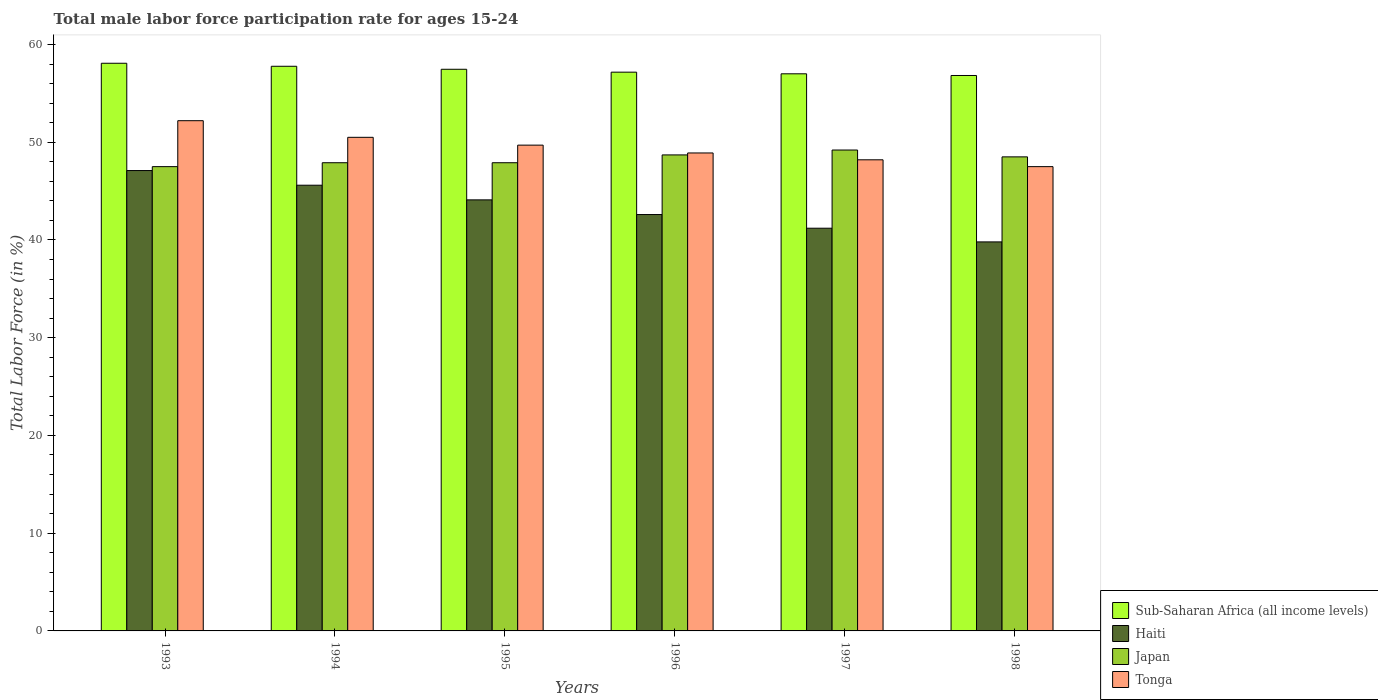How many groups of bars are there?
Provide a short and direct response. 6. Are the number of bars on each tick of the X-axis equal?
Ensure brevity in your answer.  Yes. How many bars are there on the 5th tick from the left?
Offer a terse response. 4. How many bars are there on the 1st tick from the right?
Give a very brief answer. 4. What is the male labor force participation rate in Haiti in 1995?
Your answer should be very brief. 44.1. Across all years, what is the maximum male labor force participation rate in Sub-Saharan Africa (all income levels)?
Offer a terse response. 58.08. Across all years, what is the minimum male labor force participation rate in Japan?
Ensure brevity in your answer.  47.5. In which year was the male labor force participation rate in Tonga minimum?
Ensure brevity in your answer.  1998. What is the total male labor force participation rate in Haiti in the graph?
Offer a terse response. 260.4. What is the difference between the male labor force participation rate in Sub-Saharan Africa (all income levels) in 1997 and that in 1998?
Your response must be concise. 0.17. What is the difference between the male labor force participation rate in Japan in 1993 and the male labor force participation rate in Sub-Saharan Africa (all income levels) in 1995?
Your response must be concise. -9.96. What is the average male labor force participation rate in Tonga per year?
Your response must be concise. 49.5. In the year 1995, what is the difference between the male labor force participation rate in Tonga and male labor force participation rate in Sub-Saharan Africa (all income levels)?
Your answer should be compact. -7.76. In how many years, is the male labor force participation rate in Sub-Saharan Africa (all income levels) greater than 52 %?
Make the answer very short. 6. What is the ratio of the male labor force participation rate in Haiti in 1994 to that in 1998?
Ensure brevity in your answer.  1.15. Is the male labor force participation rate in Tonga in 1995 less than that in 1998?
Keep it short and to the point. No. Is the difference between the male labor force participation rate in Tonga in 1995 and 1996 greater than the difference between the male labor force participation rate in Sub-Saharan Africa (all income levels) in 1995 and 1996?
Provide a short and direct response. Yes. What is the difference between the highest and the second highest male labor force participation rate in Haiti?
Ensure brevity in your answer.  1.5. What is the difference between the highest and the lowest male labor force participation rate in Japan?
Keep it short and to the point. 1.7. What does the 2nd bar from the left in 1997 represents?
Ensure brevity in your answer.  Haiti. What does the 2nd bar from the right in 1996 represents?
Your response must be concise. Japan. Is it the case that in every year, the sum of the male labor force participation rate in Haiti and male labor force participation rate in Tonga is greater than the male labor force participation rate in Japan?
Your answer should be compact. Yes. How many bars are there?
Keep it short and to the point. 24. Are all the bars in the graph horizontal?
Your answer should be compact. No. What is the difference between two consecutive major ticks on the Y-axis?
Make the answer very short. 10. Where does the legend appear in the graph?
Keep it short and to the point. Bottom right. How are the legend labels stacked?
Give a very brief answer. Vertical. What is the title of the graph?
Ensure brevity in your answer.  Total male labor force participation rate for ages 15-24. Does "Mauritania" appear as one of the legend labels in the graph?
Provide a short and direct response. No. What is the Total Labor Force (in %) of Sub-Saharan Africa (all income levels) in 1993?
Offer a very short reply. 58.08. What is the Total Labor Force (in %) in Haiti in 1993?
Your response must be concise. 47.1. What is the Total Labor Force (in %) of Japan in 1993?
Keep it short and to the point. 47.5. What is the Total Labor Force (in %) of Tonga in 1993?
Ensure brevity in your answer.  52.2. What is the Total Labor Force (in %) in Sub-Saharan Africa (all income levels) in 1994?
Your answer should be compact. 57.77. What is the Total Labor Force (in %) in Haiti in 1994?
Make the answer very short. 45.6. What is the Total Labor Force (in %) in Japan in 1994?
Your response must be concise. 47.9. What is the Total Labor Force (in %) in Tonga in 1994?
Provide a short and direct response. 50.5. What is the Total Labor Force (in %) in Sub-Saharan Africa (all income levels) in 1995?
Make the answer very short. 57.46. What is the Total Labor Force (in %) in Haiti in 1995?
Your answer should be compact. 44.1. What is the Total Labor Force (in %) in Japan in 1995?
Your response must be concise. 47.9. What is the Total Labor Force (in %) in Tonga in 1995?
Your answer should be compact. 49.7. What is the Total Labor Force (in %) of Sub-Saharan Africa (all income levels) in 1996?
Provide a succinct answer. 57.17. What is the Total Labor Force (in %) of Haiti in 1996?
Keep it short and to the point. 42.6. What is the Total Labor Force (in %) in Japan in 1996?
Offer a terse response. 48.7. What is the Total Labor Force (in %) of Tonga in 1996?
Your answer should be compact. 48.9. What is the Total Labor Force (in %) in Sub-Saharan Africa (all income levels) in 1997?
Your response must be concise. 57. What is the Total Labor Force (in %) in Haiti in 1997?
Your answer should be very brief. 41.2. What is the Total Labor Force (in %) of Japan in 1997?
Keep it short and to the point. 49.2. What is the Total Labor Force (in %) in Tonga in 1997?
Provide a short and direct response. 48.2. What is the Total Labor Force (in %) of Sub-Saharan Africa (all income levels) in 1998?
Make the answer very short. 56.83. What is the Total Labor Force (in %) of Haiti in 1998?
Give a very brief answer. 39.8. What is the Total Labor Force (in %) in Japan in 1998?
Your answer should be very brief. 48.5. What is the Total Labor Force (in %) in Tonga in 1998?
Offer a very short reply. 47.5. Across all years, what is the maximum Total Labor Force (in %) of Sub-Saharan Africa (all income levels)?
Offer a terse response. 58.08. Across all years, what is the maximum Total Labor Force (in %) of Haiti?
Give a very brief answer. 47.1. Across all years, what is the maximum Total Labor Force (in %) of Japan?
Make the answer very short. 49.2. Across all years, what is the maximum Total Labor Force (in %) of Tonga?
Your response must be concise. 52.2. Across all years, what is the minimum Total Labor Force (in %) of Sub-Saharan Africa (all income levels)?
Offer a terse response. 56.83. Across all years, what is the minimum Total Labor Force (in %) in Haiti?
Provide a succinct answer. 39.8. Across all years, what is the minimum Total Labor Force (in %) in Japan?
Offer a very short reply. 47.5. Across all years, what is the minimum Total Labor Force (in %) of Tonga?
Keep it short and to the point. 47.5. What is the total Total Labor Force (in %) in Sub-Saharan Africa (all income levels) in the graph?
Provide a short and direct response. 344.3. What is the total Total Labor Force (in %) in Haiti in the graph?
Make the answer very short. 260.4. What is the total Total Labor Force (in %) in Japan in the graph?
Your answer should be compact. 289.7. What is the total Total Labor Force (in %) in Tonga in the graph?
Your answer should be very brief. 297. What is the difference between the Total Labor Force (in %) in Sub-Saharan Africa (all income levels) in 1993 and that in 1994?
Offer a terse response. 0.31. What is the difference between the Total Labor Force (in %) of Japan in 1993 and that in 1994?
Keep it short and to the point. -0.4. What is the difference between the Total Labor Force (in %) in Sub-Saharan Africa (all income levels) in 1993 and that in 1995?
Offer a terse response. 0.62. What is the difference between the Total Labor Force (in %) in Haiti in 1993 and that in 1995?
Provide a short and direct response. 3. What is the difference between the Total Labor Force (in %) of Tonga in 1993 and that in 1995?
Offer a terse response. 2.5. What is the difference between the Total Labor Force (in %) of Sub-Saharan Africa (all income levels) in 1993 and that in 1996?
Ensure brevity in your answer.  0.91. What is the difference between the Total Labor Force (in %) in Japan in 1993 and that in 1996?
Keep it short and to the point. -1.2. What is the difference between the Total Labor Force (in %) of Tonga in 1993 and that in 1996?
Ensure brevity in your answer.  3.3. What is the difference between the Total Labor Force (in %) in Sub-Saharan Africa (all income levels) in 1993 and that in 1997?
Keep it short and to the point. 1.08. What is the difference between the Total Labor Force (in %) in Haiti in 1993 and that in 1997?
Offer a terse response. 5.9. What is the difference between the Total Labor Force (in %) of Sub-Saharan Africa (all income levels) in 1993 and that in 1998?
Offer a terse response. 1.25. What is the difference between the Total Labor Force (in %) in Japan in 1993 and that in 1998?
Your response must be concise. -1. What is the difference between the Total Labor Force (in %) of Tonga in 1993 and that in 1998?
Ensure brevity in your answer.  4.7. What is the difference between the Total Labor Force (in %) in Sub-Saharan Africa (all income levels) in 1994 and that in 1995?
Ensure brevity in your answer.  0.31. What is the difference between the Total Labor Force (in %) in Japan in 1994 and that in 1995?
Offer a terse response. 0. What is the difference between the Total Labor Force (in %) of Sub-Saharan Africa (all income levels) in 1994 and that in 1996?
Make the answer very short. 0.6. What is the difference between the Total Labor Force (in %) of Tonga in 1994 and that in 1996?
Give a very brief answer. 1.6. What is the difference between the Total Labor Force (in %) in Sub-Saharan Africa (all income levels) in 1994 and that in 1997?
Keep it short and to the point. 0.77. What is the difference between the Total Labor Force (in %) in Haiti in 1994 and that in 1997?
Make the answer very short. 4.4. What is the difference between the Total Labor Force (in %) in Japan in 1994 and that in 1997?
Your answer should be compact. -1.3. What is the difference between the Total Labor Force (in %) in Sub-Saharan Africa (all income levels) in 1994 and that in 1998?
Provide a short and direct response. 0.94. What is the difference between the Total Labor Force (in %) in Sub-Saharan Africa (all income levels) in 1995 and that in 1996?
Ensure brevity in your answer.  0.29. What is the difference between the Total Labor Force (in %) in Haiti in 1995 and that in 1996?
Provide a short and direct response. 1.5. What is the difference between the Total Labor Force (in %) of Japan in 1995 and that in 1996?
Your answer should be very brief. -0.8. What is the difference between the Total Labor Force (in %) of Sub-Saharan Africa (all income levels) in 1995 and that in 1997?
Your answer should be compact. 0.46. What is the difference between the Total Labor Force (in %) of Haiti in 1995 and that in 1997?
Provide a succinct answer. 2.9. What is the difference between the Total Labor Force (in %) in Tonga in 1995 and that in 1997?
Ensure brevity in your answer.  1.5. What is the difference between the Total Labor Force (in %) of Sub-Saharan Africa (all income levels) in 1995 and that in 1998?
Provide a short and direct response. 0.64. What is the difference between the Total Labor Force (in %) in Haiti in 1995 and that in 1998?
Your answer should be very brief. 4.3. What is the difference between the Total Labor Force (in %) in Japan in 1995 and that in 1998?
Ensure brevity in your answer.  -0.6. What is the difference between the Total Labor Force (in %) in Tonga in 1995 and that in 1998?
Your answer should be very brief. 2.2. What is the difference between the Total Labor Force (in %) of Sub-Saharan Africa (all income levels) in 1996 and that in 1997?
Ensure brevity in your answer.  0.17. What is the difference between the Total Labor Force (in %) of Japan in 1996 and that in 1997?
Offer a very short reply. -0.5. What is the difference between the Total Labor Force (in %) of Tonga in 1996 and that in 1997?
Offer a very short reply. 0.7. What is the difference between the Total Labor Force (in %) in Sub-Saharan Africa (all income levels) in 1996 and that in 1998?
Provide a short and direct response. 0.34. What is the difference between the Total Labor Force (in %) in Japan in 1996 and that in 1998?
Give a very brief answer. 0.2. What is the difference between the Total Labor Force (in %) in Sub-Saharan Africa (all income levels) in 1997 and that in 1998?
Offer a very short reply. 0.17. What is the difference between the Total Labor Force (in %) in Sub-Saharan Africa (all income levels) in 1993 and the Total Labor Force (in %) in Haiti in 1994?
Your response must be concise. 12.48. What is the difference between the Total Labor Force (in %) in Sub-Saharan Africa (all income levels) in 1993 and the Total Labor Force (in %) in Japan in 1994?
Give a very brief answer. 10.18. What is the difference between the Total Labor Force (in %) of Sub-Saharan Africa (all income levels) in 1993 and the Total Labor Force (in %) of Tonga in 1994?
Give a very brief answer. 7.58. What is the difference between the Total Labor Force (in %) of Haiti in 1993 and the Total Labor Force (in %) of Japan in 1994?
Your answer should be compact. -0.8. What is the difference between the Total Labor Force (in %) in Haiti in 1993 and the Total Labor Force (in %) in Tonga in 1994?
Make the answer very short. -3.4. What is the difference between the Total Labor Force (in %) of Japan in 1993 and the Total Labor Force (in %) of Tonga in 1994?
Ensure brevity in your answer.  -3. What is the difference between the Total Labor Force (in %) in Sub-Saharan Africa (all income levels) in 1993 and the Total Labor Force (in %) in Haiti in 1995?
Give a very brief answer. 13.98. What is the difference between the Total Labor Force (in %) in Sub-Saharan Africa (all income levels) in 1993 and the Total Labor Force (in %) in Japan in 1995?
Give a very brief answer. 10.18. What is the difference between the Total Labor Force (in %) in Sub-Saharan Africa (all income levels) in 1993 and the Total Labor Force (in %) in Tonga in 1995?
Offer a terse response. 8.38. What is the difference between the Total Labor Force (in %) of Sub-Saharan Africa (all income levels) in 1993 and the Total Labor Force (in %) of Haiti in 1996?
Your answer should be very brief. 15.48. What is the difference between the Total Labor Force (in %) of Sub-Saharan Africa (all income levels) in 1993 and the Total Labor Force (in %) of Japan in 1996?
Offer a terse response. 9.38. What is the difference between the Total Labor Force (in %) in Sub-Saharan Africa (all income levels) in 1993 and the Total Labor Force (in %) in Tonga in 1996?
Offer a terse response. 9.18. What is the difference between the Total Labor Force (in %) in Haiti in 1993 and the Total Labor Force (in %) in Japan in 1996?
Make the answer very short. -1.6. What is the difference between the Total Labor Force (in %) in Sub-Saharan Africa (all income levels) in 1993 and the Total Labor Force (in %) in Haiti in 1997?
Offer a terse response. 16.88. What is the difference between the Total Labor Force (in %) of Sub-Saharan Africa (all income levels) in 1993 and the Total Labor Force (in %) of Japan in 1997?
Give a very brief answer. 8.88. What is the difference between the Total Labor Force (in %) of Sub-Saharan Africa (all income levels) in 1993 and the Total Labor Force (in %) of Tonga in 1997?
Offer a very short reply. 9.88. What is the difference between the Total Labor Force (in %) in Haiti in 1993 and the Total Labor Force (in %) in Japan in 1997?
Offer a terse response. -2.1. What is the difference between the Total Labor Force (in %) of Haiti in 1993 and the Total Labor Force (in %) of Tonga in 1997?
Make the answer very short. -1.1. What is the difference between the Total Labor Force (in %) in Sub-Saharan Africa (all income levels) in 1993 and the Total Labor Force (in %) in Haiti in 1998?
Provide a short and direct response. 18.28. What is the difference between the Total Labor Force (in %) of Sub-Saharan Africa (all income levels) in 1993 and the Total Labor Force (in %) of Japan in 1998?
Your answer should be very brief. 9.58. What is the difference between the Total Labor Force (in %) of Sub-Saharan Africa (all income levels) in 1993 and the Total Labor Force (in %) of Tonga in 1998?
Your answer should be compact. 10.58. What is the difference between the Total Labor Force (in %) of Haiti in 1993 and the Total Labor Force (in %) of Japan in 1998?
Provide a succinct answer. -1.4. What is the difference between the Total Labor Force (in %) of Haiti in 1993 and the Total Labor Force (in %) of Tonga in 1998?
Offer a terse response. -0.4. What is the difference between the Total Labor Force (in %) of Sub-Saharan Africa (all income levels) in 1994 and the Total Labor Force (in %) of Haiti in 1995?
Provide a short and direct response. 13.67. What is the difference between the Total Labor Force (in %) in Sub-Saharan Africa (all income levels) in 1994 and the Total Labor Force (in %) in Japan in 1995?
Your response must be concise. 9.87. What is the difference between the Total Labor Force (in %) in Sub-Saharan Africa (all income levels) in 1994 and the Total Labor Force (in %) in Tonga in 1995?
Offer a terse response. 8.07. What is the difference between the Total Labor Force (in %) in Haiti in 1994 and the Total Labor Force (in %) in Japan in 1995?
Give a very brief answer. -2.3. What is the difference between the Total Labor Force (in %) of Haiti in 1994 and the Total Labor Force (in %) of Tonga in 1995?
Your answer should be compact. -4.1. What is the difference between the Total Labor Force (in %) of Japan in 1994 and the Total Labor Force (in %) of Tonga in 1995?
Give a very brief answer. -1.8. What is the difference between the Total Labor Force (in %) in Sub-Saharan Africa (all income levels) in 1994 and the Total Labor Force (in %) in Haiti in 1996?
Provide a succinct answer. 15.17. What is the difference between the Total Labor Force (in %) in Sub-Saharan Africa (all income levels) in 1994 and the Total Labor Force (in %) in Japan in 1996?
Your answer should be very brief. 9.07. What is the difference between the Total Labor Force (in %) in Sub-Saharan Africa (all income levels) in 1994 and the Total Labor Force (in %) in Tonga in 1996?
Your answer should be compact. 8.87. What is the difference between the Total Labor Force (in %) in Haiti in 1994 and the Total Labor Force (in %) in Tonga in 1996?
Your answer should be very brief. -3.3. What is the difference between the Total Labor Force (in %) in Japan in 1994 and the Total Labor Force (in %) in Tonga in 1996?
Ensure brevity in your answer.  -1. What is the difference between the Total Labor Force (in %) of Sub-Saharan Africa (all income levels) in 1994 and the Total Labor Force (in %) of Haiti in 1997?
Offer a terse response. 16.57. What is the difference between the Total Labor Force (in %) of Sub-Saharan Africa (all income levels) in 1994 and the Total Labor Force (in %) of Japan in 1997?
Your response must be concise. 8.57. What is the difference between the Total Labor Force (in %) in Sub-Saharan Africa (all income levels) in 1994 and the Total Labor Force (in %) in Tonga in 1997?
Your answer should be very brief. 9.57. What is the difference between the Total Labor Force (in %) in Haiti in 1994 and the Total Labor Force (in %) in Japan in 1997?
Provide a short and direct response. -3.6. What is the difference between the Total Labor Force (in %) in Haiti in 1994 and the Total Labor Force (in %) in Tonga in 1997?
Offer a very short reply. -2.6. What is the difference between the Total Labor Force (in %) of Japan in 1994 and the Total Labor Force (in %) of Tonga in 1997?
Your response must be concise. -0.3. What is the difference between the Total Labor Force (in %) of Sub-Saharan Africa (all income levels) in 1994 and the Total Labor Force (in %) of Haiti in 1998?
Offer a very short reply. 17.97. What is the difference between the Total Labor Force (in %) of Sub-Saharan Africa (all income levels) in 1994 and the Total Labor Force (in %) of Japan in 1998?
Provide a short and direct response. 9.27. What is the difference between the Total Labor Force (in %) of Sub-Saharan Africa (all income levels) in 1994 and the Total Labor Force (in %) of Tonga in 1998?
Give a very brief answer. 10.27. What is the difference between the Total Labor Force (in %) of Japan in 1994 and the Total Labor Force (in %) of Tonga in 1998?
Provide a succinct answer. 0.4. What is the difference between the Total Labor Force (in %) in Sub-Saharan Africa (all income levels) in 1995 and the Total Labor Force (in %) in Haiti in 1996?
Offer a very short reply. 14.86. What is the difference between the Total Labor Force (in %) of Sub-Saharan Africa (all income levels) in 1995 and the Total Labor Force (in %) of Japan in 1996?
Offer a very short reply. 8.76. What is the difference between the Total Labor Force (in %) in Sub-Saharan Africa (all income levels) in 1995 and the Total Labor Force (in %) in Tonga in 1996?
Keep it short and to the point. 8.56. What is the difference between the Total Labor Force (in %) of Haiti in 1995 and the Total Labor Force (in %) of Japan in 1996?
Offer a terse response. -4.6. What is the difference between the Total Labor Force (in %) in Japan in 1995 and the Total Labor Force (in %) in Tonga in 1996?
Provide a succinct answer. -1. What is the difference between the Total Labor Force (in %) in Sub-Saharan Africa (all income levels) in 1995 and the Total Labor Force (in %) in Haiti in 1997?
Give a very brief answer. 16.26. What is the difference between the Total Labor Force (in %) of Sub-Saharan Africa (all income levels) in 1995 and the Total Labor Force (in %) of Japan in 1997?
Provide a succinct answer. 8.26. What is the difference between the Total Labor Force (in %) in Sub-Saharan Africa (all income levels) in 1995 and the Total Labor Force (in %) in Tonga in 1997?
Your answer should be compact. 9.26. What is the difference between the Total Labor Force (in %) in Haiti in 1995 and the Total Labor Force (in %) in Japan in 1997?
Offer a terse response. -5.1. What is the difference between the Total Labor Force (in %) in Haiti in 1995 and the Total Labor Force (in %) in Tonga in 1997?
Give a very brief answer. -4.1. What is the difference between the Total Labor Force (in %) of Sub-Saharan Africa (all income levels) in 1995 and the Total Labor Force (in %) of Haiti in 1998?
Make the answer very short. 17.66. What is the difference between the Total Labor Force (in %) of Sub-Saharan Africa (all income levels) in 1995 and the Total Labor Force (in %) of Japan in 1998?
Ensure brevity in your answer.  8.96. What is the difference between the Total Labor Force (in %) of Sub-Saharan Africa (all income levels) in 1995 and the Total Labor Force (in %) of Tonga in 1998?
Provide a succinct answer. 9.96. What is the difference between the Total Labor Force (in %) in Haiti in 1995 and the Total Labor Force (in %) in Japan in 1998?
Offer a terse response. -4.4. What is the difference between the Total Labor Force (in %) of Haiti in 1995 and the Total Labor Force (in %) of Tonga in 1998?
Keep it short and to the point. -3.4. What is the difference between the Total Labor Force (in %) of Japan in 1995 and the Total Labor Force (in %) of Tonga in 1998?
Your response must be concise. 0.4. What is the difference between the Total Labor Force (in %) of Sub-Saharan Africa (all income levels) in 1996 and the Total Labor Force (in %) of Haiti in 1997?
Ensure brevity in your answer.  15.97. What is the difference between the Total Labor Force (in %) in Sub-Saharan Africa (all income levels) in 1996 and the Total Labor Force (in %) in Japan in 1997?
Provide a short and direct response. 7.97. What is the difference between the Total Labor Force (in %) of Sub-Saharan Africa (all income levels) in 1996 and the Total Labor Force (in %) of Tonga in 1997?
Offer a very short reply. 8.97. What is the difference between the Total Labor Force (in %) in Japan in 1996 and the Total Labor Force (in %) in Tonga in 1997?
Make the answer very short. 0.5. What is the difference between the Total Labor Force (in %) in Sub-Saharan Africa (all income levels) in 1996 and the Total Labor Force (in %) in Haiti in 1998?
Make the answer very short. 17.37. What is the difference between the Total Labor Force (in %) in Sub-Saharan Africa (all income levels) in 1996 and the Total Labor Force (in %) in Japan in 1998?
Ensure brevity in your answer.  8.67. What is the difference between the Total Labor Force (in %) of Sub-Saharan Africa (all income levels) in 1996 and the Total Labor Force (in %) of Tonga in 1998?
Provide a short and direct response. 9.67. What is the difference between the Total Labor Force (in %) in Japan in 1996 and the Total Labor Force (in %) in Tonga in 1998?
Make the answer very short. 1.2. What is the difference between the Total Labor Force (in %) in Sub-Saharan Africa (all income levels) in 1997 and the Total Labor Force (in %) in Haiti in 1998?
Ensure brevity in your answer.  17.2. What is the difference between the Total Labor Force (in %) of Sub-Saharan Africa (all income levels) in 1997 and the Total Labor Force (in %) of Japan in 1998?
Your response must be concise. 8.5. What is the difference between the Total Labor Force (in %) of Sub-Saharan Africa (all income levels) in 1997 and the Total Labor Force (in %) of Tonga in 1998?
Give a very brief answer. 9.5. What is the difference between the Total Labor Force (in %) of Japan in 1997 and the Total Labor Force (in %) of Tonga in 1998?
Your answer should be compact. 1.7. What is the average Total Labor Force (in %) in Sub-Saharan Africa (all income levels) per year?
Keep it short and to the point. 57.38. What is the average Total Labor Force (in %) of Haiti per year?
Your response must be concise. 43.4. What is the average Total Labor Force (in %) in Japan per year?
Provide a succinct answer. 48.28. What is the average Total Labor Force (in %) in Tonga per year?
Make the answer very short. 49.5. In the year 1993, what is the difference between the Total Labor Force (in %) of Sub-Saharan Africa (all income levels) and Total Labor Force (in %) of Haiti?
Your answer should be very brief. 10.98. In the year 1993, what is the difference between the Total Labor Force (in %) in Sub-Saharan Africa (all income levels) and Total Labor Force (in %) in Japan?
Offer a terse response. 10.58. In the year 1993, what is the difference between the Total Labor Force (in %) of Sub-Saharan Africa (all income levels) and Total Labor Force (in %) of Tonga?
Ensure brevity in your answer.  5.88. In the year 1993, what is the difference between the Total Labor Force (in %) of Japan and Total Labor Force (in %) of Tonga?
Your response must be concise. -4.7. In the year 1994, what is the difference between the Total Labor Force (in %) in Sub-Saharan Africa (all income levels) and Total Labor Force (in %) in Haiti?
Make the answer very short. 12.17. In the year 1994, what is the difference between the Total Labor Force (in %) in Sub-Saharan Africa (all income levels) and Total Labor Force (in %) in Japan?
Your answer should be compact. 9.87. In the year 1994, what is the difference between the Total Labor Force (in %) of Sub-Saharan Africa (all income levels) and Total Labor Force (in %) of Tonga?
Offer a terse response. 7.27. In the year 1994, what is the difference between the Total Labor Force (in %) of Haiti and Total Labor Force (in %) of Tonga?
Give a very brief answer. -4.9. In the year 1995, what is the difference between the Total Labor Force (in %) of Sub-Saharan Africa (all income levels) and Total Labor Force (in %) of Haiti?
Provide a short and direct response. 13.36. In the year 1995, what is the difference between the Total Labor Force (in %) in Sub-Saharan Africa (all income levels) and Total Labor Force (in %) in Japan?
Provide a short and direct response. 9.56. In the year 1995, what is the difference between the Total Labor Force (in %) in Sub-Saharan Africa (all income levels) and Total Labor Force (in %) in Tonga?
Your response must be concise. 7.76. In the year 1995, what is the difference between the Total Labor Force (in %) in Haiti and Total Labor Force (in %) in Japan?
Offer a very short reply. -3.8. In the year 1996, what is the difference between the Total Labor Force (in %) in Sub-Saharan Africa (all income levels) and Total Labor Force (in %) in Haiti?
Make the answer very short. 14.57. In the year 1996, what is the difference between the Total Labor Force (in %) in Sub-Saharan Africa (all income levels) and Total Labor Force (in %) in Japan?
Your response must be concise. 8.47. In the year 1996, what is the difference between the Total Labor Force (in %) in Sub-Saharan Africa (all income levels) and Total Labor Force (in %) in Tonga?
Make the answer very short. 8.27. In the year 1996, what is the difference between the Total Labor Force (in %) in Haiti and Total Labor Force (in %) in Japan?
Offer a very short reply. -6.1. In the year 1996, what is the difference between the Total Labor Force (in %) in Haiti and Total Labor Force (in %) in Tonga?
Your answer should be compact. -6.3. In the year 1996, what is the difference between the Total Labor Force (in %) in Japan and Total Labor Force (in %) in Tonga?
Provide a succinct answer. -0.2. In the year 1997, what is the difference between the Total Labor Force (in %) in Sub-Saharan Africa (all income levels) and Total Labor Force (in %) in Haiti?
Provide a short and direct response. 15.8. In the year 1997, what is the difference between the Total Labor Force (in %) of Sub-Saharan Africa (all income levels) and Total Labor Force (in %) of Japan?
Offer a very short reply. 7.8. In the year 1997, what is the difference between the Total Labor Force (in %) of Sub-Saharan Africa (all income levels) and Total Labor Force (in %) of Tonga?
Offer a terse response. 8.8. In the year 1998, what is the difference between the Total Labor Force (in %) in Sub-Saharan Africa (all income levels) and Total Labor Force (in %) in Haiti?
Your answer should be compact. 17.03. In the year 1998, what is the difference between the Total Labor Force (in %) in Sub-Saharan Africa (all income levels) and Total Labor Force (in %) in Japan?
Keep it short and to the point. 8.33. In the year 1998, what is the difference between the Total Labor Force (in %) of Sub-Saharan Africa (all income levels) and Total Labor Force (in %) of Tonga?
Give a very brief answer. 9.33. What is the ratio of the Total Labor Force (in %) in Haiti in 1993 to that in 1994?
Make the answer very short. 1.03. What is the ratio of the Total Labor Force (in %) in Tonga in 1993 to that in 1994?
Make the answer very short. 1.03. What is the ratio of the Total Labor Force (in %) of Sub-Saharan Africa (all income levels) in 1993 to that in 1995?
Your answer should be very brief. 1.01. What is the ratio of the Total Labor Force (in %) in Haiti in 1993 to that in 1995?
Offer a terse response. 1.07. What is the ratio of the Total Labor Force (in %) in Japan in 1993 to that in 1995?
Your response must be concise. 0.99. What is the ratio of the Total Labor Force (in %) in Tonga in 1993 to that in 1995?
Your answer should be very brief. 1.05. What is the ratio of the Total Labor Force (in %) of Sub-Saharan Africa (all income levels) in 1993 to that in 1996?
Offer a terse response. 1.02. What is the ratio of the Total Labor Force (in %) of Haiti in 1993 to that in 1996?
Offer a very short reply. 1.11. What is the ratio of the Total Labor Force (in %) of Japan in 1993 to that in 1996?
Give a very brief answer. 0.98. What is the ratio of the Total Labor Force (in %) of Tonga in 1993 to that in 1996?
Your answer should be compact. 1.07. What is the ratio of the Total Labor Force (in %) of Sub-Saharan Africa (all income levels) in 1993 to that in 1997?
Make the answer very short. 1.02. What is the ratio of the Total Labor Force (in %) in Haiti in 1993 to that in 1997?
Provide a succinct answer. 1.14. What is the ratio of the Total Labor Force (in %) in Japan in 1993 to that in 1997?
Provide a succinct answer. 0.97. What is the ratio of the Total Labor Force (in %) in Tonga in 1993 to that in 1997?
Your answer should be compact. 1.08. What is the ratio of the Total Labor Force (in %) of Sub-Saharan Africa (all income levels) in 1993 to that in 1998?
Your answer should be compact. 1.02. What is the ratio of the Total Labor Force (in %) in Haiti in 1993 to that in 1998?
Your response must be concise. 1.18. What is the ratio of the Total Labor Force (in %) of Japan in 1993 to that in 1998?
Give a very brief answer. 0.98. What is the ratio of the Total Labor Force (in %) in Tonga in 1993 to that in 1998?
Offer a terse response. 1.1. What is the ratio of the Total Labor Force (in %) of Sub-Saharan Africa (all income levels) in 1994 to that in 1995?
Make the answer very short. 1.01. What is the ratio of the Total Labor Force (in %) in Haiti in 1994 to that in 1995?
Make the answer very short. 1.03. What is the ratio of the Total Labor Force (in %) in Japan in 1994 to that in 1995?
Your answer should be very brief. 1. What is the ratio of the Total Labor Force (in %) in Tonga in 1994 to that in 1995?
Your answer should be compact. 1.02. What is the ratio of the Total Labor Force (in %) in Sub-Saharan Africa (all income levels) in 1994 to that in 1996?
Give a very brief answer. 1.01. What is the ratio of the Total Labor Force (in %) of Haiti in 1994 to that in 1996?
Give a very brief answer. 1.07. What is the ratio of the Total Labor Force (in %) in Japan in 1994 to that in 1996?
Your answer should be compact. 0.98. What is the ratio of the Total Labor Force (in %) of Tonga in 1994 to that in 1996?
Your answer should be compact. 1.03. What is the ratio of the Total Labor Force (in %) of Sub-Saharan Africa (all income levels) in 1994 to that in 1997?
Keep it short and to the point. 1.01. What is the ratio of the Total Labor Force (in %) of Haiti in 1994 to that in 1997?
Your response must be concise. 1.11. What is the ratio of the Total Labor Force (in %) of Japan in 1994 to that in 1997?
Your answer should be very brief. 0.97. What is the ratio of the Total Labor Force (in %) of Tonga in 1994 to that in 1997?
Your answer should be compact. 1.05. What is the ratio of the Total Labor Force (in %) in Sub-Saharan Africa (all income levels) in 1994 to that in 1998?
Your answer should be compact. 1.02. What is the ratio of the Total Labor Force (in %) of Haiti in 1994 to that in 1998?
Provide a short and direct response. 1.15. What is the ratio of the Total Labor Force (in %) of Japan in 1994 to that in 1998?
Offer a very short reply. 0.99. What is the ratio of the Total Labor Force (in %) in Tonga in 1994 to that in 1998?
Offer a terse response. 1.06. What is the ratio of the Total Labor Force (in %) of Haiti in 1995 to that in 1996?
Offer a terse response. 1.04. What is the ratio of the Total Labor Force (in %) of Japan in 1995 to that in 1996?
Make the answer very short. 0.98. What is the ratio of the Total Labor Force (in %) in Tonga in 1995 to that in 1996?
Make the answer very short. 1.02. What is the ratio of the Total Labor Force (in %) in Sub-Saharan Africa (all income levels) in 1995 to that in 1997?
Ensure brevity in your answer.  1.01. What is the ratio of the Total Labor Force (in %) in Haiti in 1995 to that in 1997?
Your answer should be very brief. 1.07. What is the ratio of the Total Labor Force (in %) in Japan in 1995 to that in 1997?
Provide a succinct answer. 0.97. What is the ratio of the Total Labor Force (in %) in Tonga in 1995 to that in 1997?
Your answer should be compact. 1.03. What is the ratio of the Total Labor Force (in %) in Sub-Saharan Africa (all income levels) in 1995 to that in 1998?
Offer a terse response. 1.01. What is the ratio of the Total Labor Force (in %) of Haiti in 1995 to that in 1998?
Ensure brevity in your answer.  1.11. What is the ratio of the Total Labor Force (in %) in Japan in 1995 to that in 1998?
Make the answer very short. 0.99. What is the ratio of the Total Labor Force (in %) in Tonga in 1995 to that in 1998?
Offer a very short reply. 1.05. What is the ratio of the Total Labor Force (in %) of Haiti in 1996 to that in 1997?
Offer a very short reply. 1.03. What is the ratio of the Total Labor Force (in %) of Japan in 1996 to that in 1997?
Your answer should be very brief. 0.99. What is the ratio of the Total Labor Force (in %) of Tonga in 1996 to that in 1997?
Your response must be concise. 1.01. What is the ratio of the Total Labor Force (in %) in Sub-Saharan Africa (all income levels) in 1996 to that in 1998?
Your answer should be very brief. 1.01. What is the ratio of the Total Labor Force (in %) in Haiti in 1996 to that in 1998?
Your response must be concise. 1.07. What is the ratio of the Total Labor Force (in %) of Tonga in 1996 to that in 1998?
Keep it short and to the point. 1.03. What is the ratio of the Total Labor Force (in %) of Sub-Saharan Africa (all income levels) in 1997 to that in 1998?
Your answer should be very brief. 1. What is the ratio of the Total Labor Force (in %) of Haiti in 1997 to that in 1998?
Your answer should be compact. 1.04. What is the ratio of the Total Labor Force (in %) of Japan in 1997 to that in 1998?
Give a very brief answer. 1.01. What is the ratio of the Total Labor Force (in %) of Tonga in 1997 to that in 1998?
Keep it short and to the point. 1.01. What is the difference between the highest and the second highest Total Labor Force (in %) in Sub-Saharan Africa (all income levels)?
Your answer should be very brief. 0.31. What is the difference between the highest and the second highest Total Labor Force (in %) of Haiti?
Keep it short and to the point. 1.5. What is the difference between the highest and the second highest Total Labor Force (in %) of Japan?
Your answer should be compact. 0.5. What is the difference between the highest and the lowest Total Labor Force (in %) in Sub-Saharan Africa (all income levels)?
Keep it short and to the point. 1.25. 